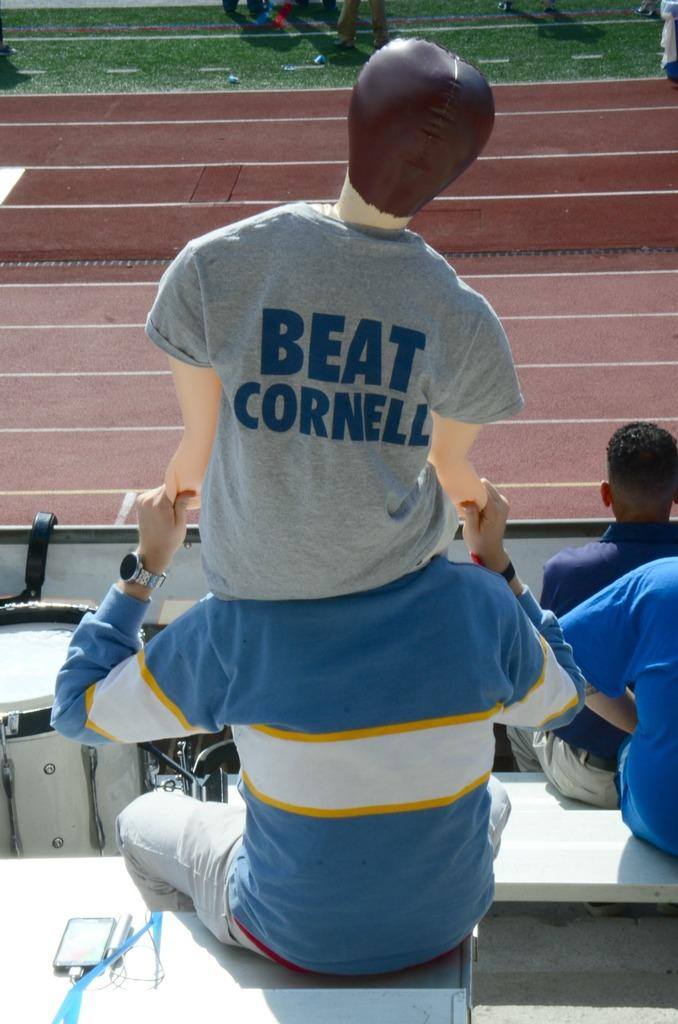<image>
Give a short and clear explanation of the subsequent image. A man sitting in the bleachers watching some type of event holding a blow up doll on his shoulders that is wearing a shirt that says BEAT CORNELL. 